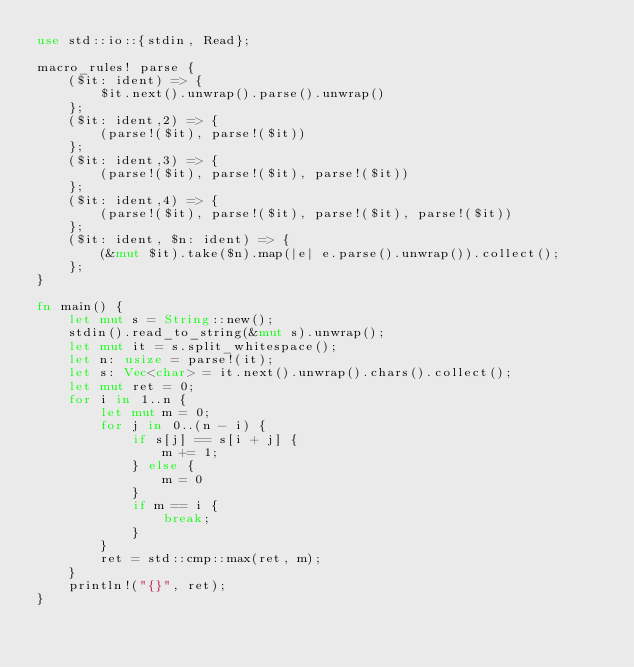<code> <loc_0><loc_0><loc_500><loc_500><_Rust_>use std::io::{stdin, Read};

macro_rules! parse {
    ($it: ident) => {
        $it.next().unwrap().parse().unwrap()
    };
    ($it: ident,2) => {
        (parse!($it), parse!($it))
    };
    ($it: ident,3) => {
        (parse!($it), parse!($it), parse!($it))
    };
    ($it: ident,4) => {
        (parse!($it), parse!($it), parse!($it), parse!($it))
    };
    ($it: ident, $n: ident) => {
        (&mut $it).take($n).map(|e| e.parse().unwrap()).collect();
    };
}

fn main() {
    let mut s = String::new();
    stdin().read_to_string(&mut s).unwrap();
    let mut it = s.split_whitespace();
    let n: usize = parse!(it);
    let s: Vec<char> = it.next().unwrap().chars().collect();
    let mut ret = 0;
    for i in 1..n {
        let mut m = 0;
        for j in 0..(n - i) {
            if s[j] == s[i + j] {
                m += 1;
            } else {
                m = 0
            }
            if m == i {
                break;
            }
        }
        ret = std::cmp::max(ret, m);
    }
    println!("{}", ret);
}
</code> 